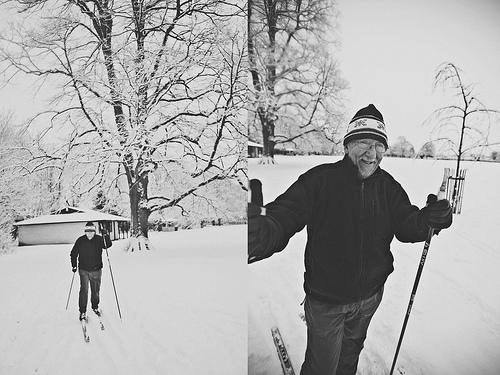Question: why is the man holding ski poles?
Choices:
A. Because he is skiing.
B. To help him ski.
C. To help him balance.
D. To learn to ski.
Answer with the letter. Answer: B Question: what is on his head?
Choices:
A. Beanie.
B. Hat.
C. Knit cap.
D. Ski mask.
Answer with the letter. Answer: C Question: what is the man doing?
Choices:
A. Walking.
B. Skiing.
C. Sleeping.
D. Eating.
Answer with the letter. Answer: B 